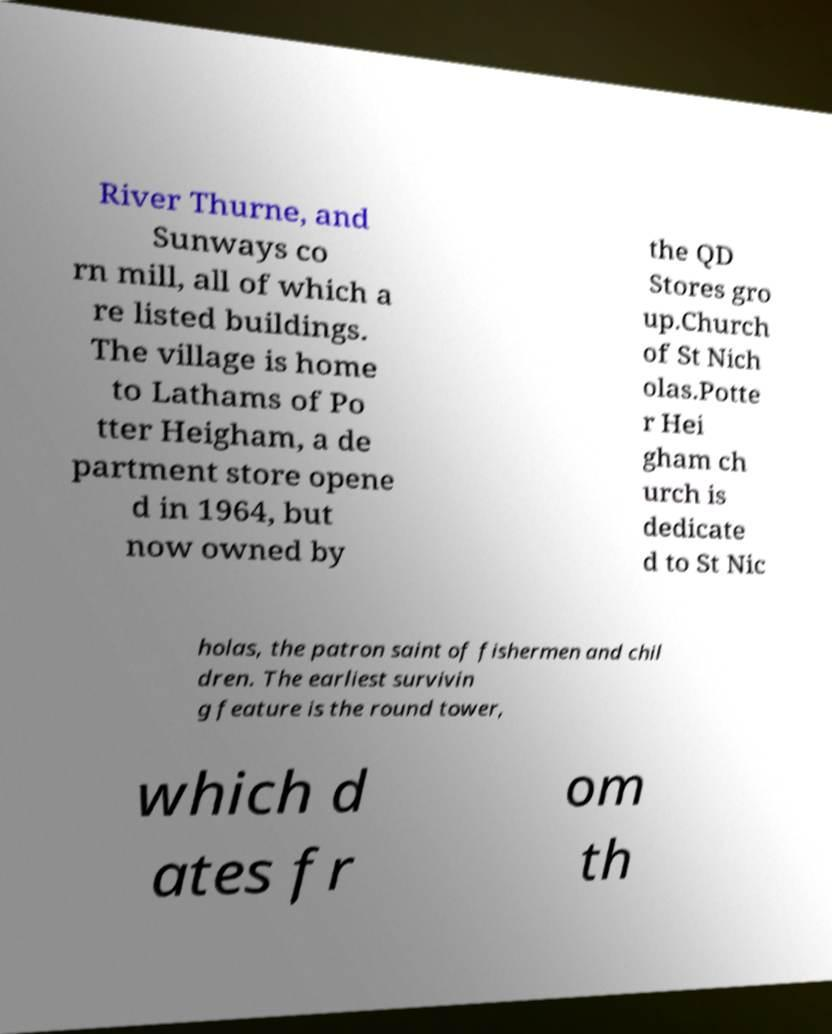Please read and relay the text visible in this image. What does it say? River Thurne, and Sunways co rn mill, all of which a re listed buildings. The village is home to Lathams of Po tter Heigham, a de partment store opene d in 1964, but now owned by the QD Stores gro up.Church of St Nich olas.Potte r Hei gham ch urch is dedicate d to St Nic holas, the patron saint of fishermen and chil dren. The earliest survivin g feature is the round tower, which d ates fr om th 